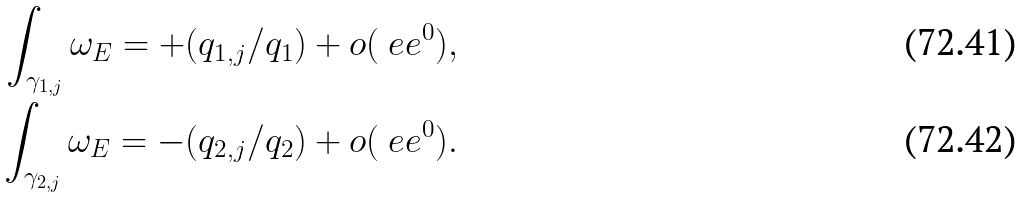Convert formula to latex. <formula><loc_0><loc_0><loc_500><loc_500>\int _ { \gamma _ { 1 , j } } { \omega _ { E } } = + ( q _ { 1 , j } / q _ { 1 } ) + o ( \ e e ^ { 0 } ) , \\ \int _ { \gamma _ { 2 , j } } { \omega _ { E } } = - ( q _ { 2 , j } / q _ { 2 } ) + o ( \ e e ^ { 0 } ) .</formula> 